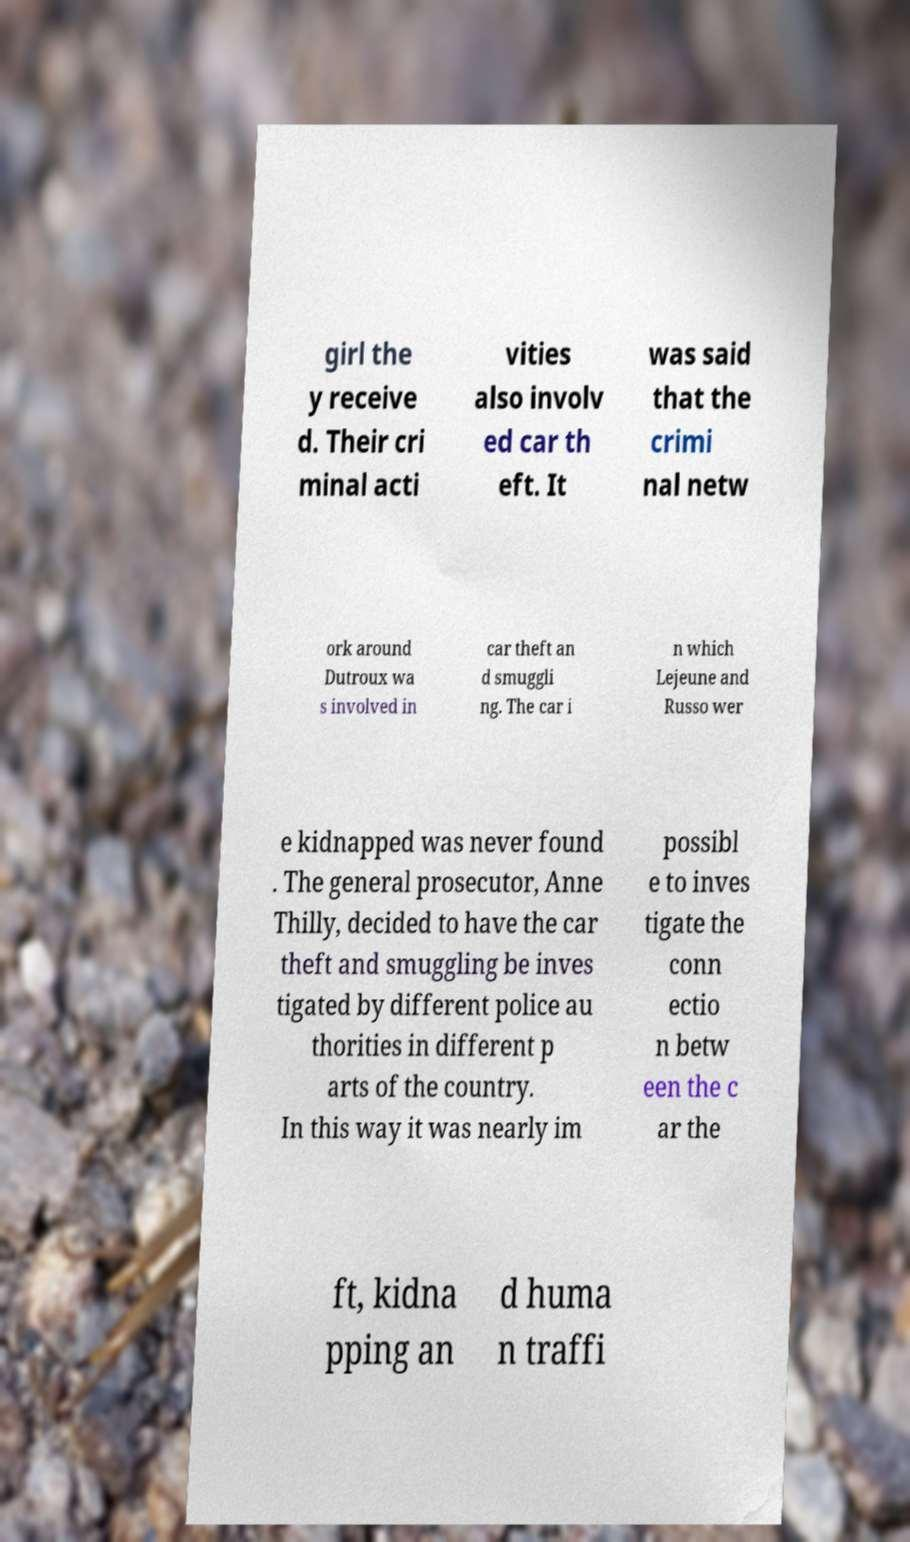Can you accurately transcribe the text from the provided image for me? girl the y receive d. Their cri minal acti vities also involv ed car th eft. It was said that the crimi nal netw ork around Dutroux wa s involved in car theft an d smuggli ng. The car i n which Lejeune and Russo wer e kidnapped was never found . The general prosecutor, Anne Thilly, decided to have the car theft and smuggling be inves tigated by different police au thorities in different p arts of the country. In this way it was nearly im possibl e to inves tigate the conn ectio n betw een the c ar the ft, kidna pping an d huma n traffi 